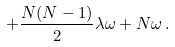Convert formula to latex. <formula><loc_0><loc_0><loc_500><loc_500>+ \frac { N ( N - 1 ) } { 2 } \lambda \omega + N \omega \, .</formula> 